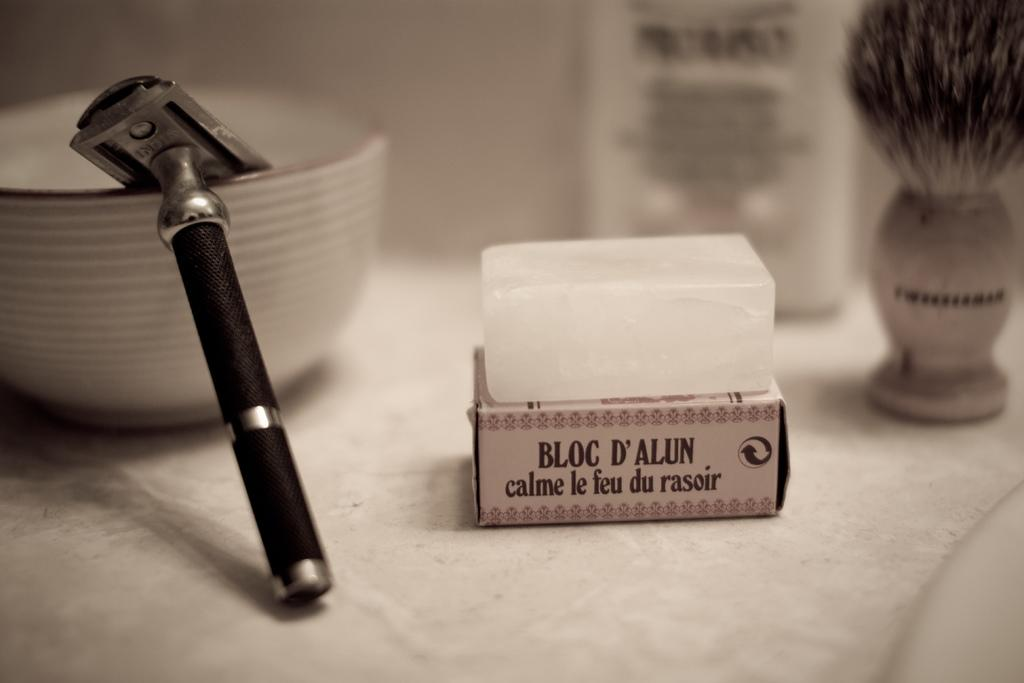<image>
Render a clear and concise summary of the photo. A razor sits in a bowl next to a Bloc D'Alun calme le feu du rasoir 